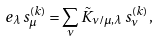<formula> <loc_0><loc_0><loc_500><loc_500>e _ { \lambda } \, s _ { \mu } ^ { ( k ) } = \sum _ { \nu } \tilde { K } _ { \nu / \mu , \lambda } \, s _ { \nu } ^ { ( k ) } \, ,</formula> 